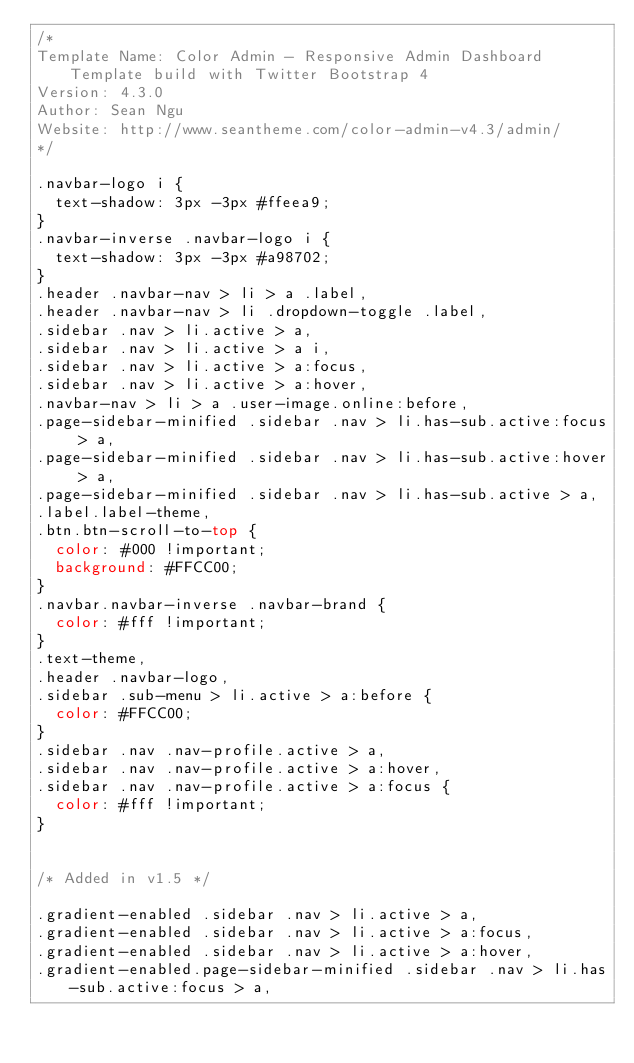<code> <loc_0><loc_0><loc_500><loc_500><_CSS_>/*
Template Name: Color Admin - Responsive Admin Dashboard Template build with Twitter Bootstrap 4
Version: 4.3.0
Author: Sean Ngu
Website: http://www.seantheme.com/color-admin-v4.3/admin/
*/

.navbar-logo i {
	text-shadow: 3px -3px #ffeea9;
}
.navbar-inverse .navbar-logo i {
	text-shadow: 3px -3px #a98702;
}
.header .navbar-nav > li > a .label,
.header .navbar-nav > li .dropdown-toggle .label,
.sidebar .nav > li.active > a, 
.sidebar .nav > li.active > a i,
.sidebar .nav > li.active > a:focus, 
.sidebar .nav > li.active > a:hover,
.navbar-nav > li > a .user-image.online:before,
.page-sidebar-minified .sidebar .nav > li.has-sub.active:focus > a, 
.page-sidebar-minified .sidebar .nav > li.has-sub.active:hover > a, 
.page-sidebar-minified .sidebar .nav > li.has-sub.active > a,
.label.label-theme,
.btn.btn-scroll-to-top {
	color: #000 !important;
	background: #FFCC00;
}
.navbar.navbar-inverse .navbar-brand {
	color: #fff !important;
}
.text-theme,
.header .navbar-logo,
.sidebar .sub-menu > li.active > a:before {
	color: #FFCC00;
}
.sidebar .nav .nav-profile.active > a,
.sidebar .nav .nav-profile.active > a:hover,
.sidebar .nav .nav-profile.active > a:focus {
	color: #fff !important;
}


/* Added in v1.5 */

.gradient-enabled .sidebar .nav > li.active > a, 
.gradient-enabled .sidebar .nav > li.active > a:focus, 
.gradient-enabled .sidebar .nav > li.active > a:hover,
.gradient-enabled.page-sidebar-minified .sidebar .nav > li.has-sub.active:focus > a, </code> 